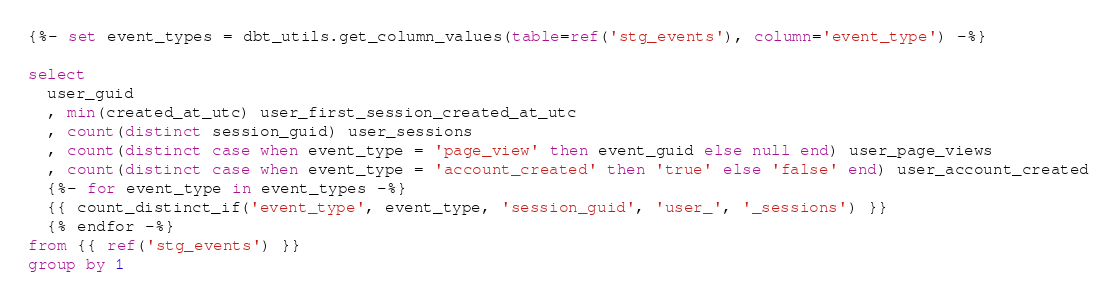Convert code to text. <code><loc_0><loc_0><loc_500><loc_500><_SQL_>{%- set event_types = dbt_utils.get_column_values(table=ref('stg_events'), column='event_type') -%}

select
  user_guid
  , min(created_at_utc) user_first_session_created_at_utc
  , count(distinct session_guid) user_sessions
  , count(distinct case when event_type = 'page_view' then event_guid else null end) user_page_views
  , count(distinct case when event_type = 'account_created' then 'true' else 'false' end) user_account_created
  {%- for event_type in event_types -%}
  {{ count_distinct_if('event_type', event_type, 'session_guid', 'user_', '_sessions') }}
  {% endfor -%}
from {{ ref('stg_events') }}
group by 1</code> 